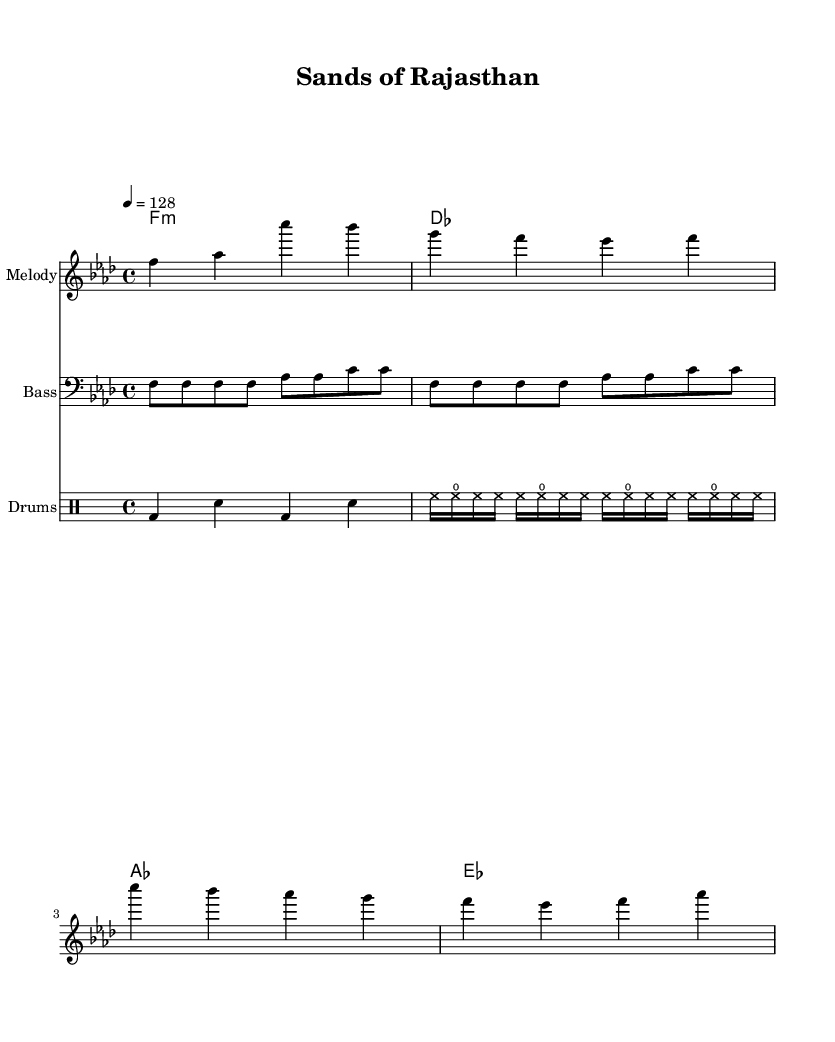What is the key signature of this music? The key signature is F minor, which has four flats. You can identify this by looking at the beginning of the staff where the flats are placed.
Answer: F minor What is the time signature of this piece? The time signature is 4/4, indicated at the beginning of the score. This means there are four beats in each measure.
Answer: 4/4 What is the tempo marking provided in the score? The tempo marking indicates a speed of 128 beats per minute. This is noted above the staff as "4 = 128."
Answer: 128 How many measures are in the melody section? Counting the melody notes visually, the melody contains eight measures. Each measure corresponds to a distinct grouping of beats.
Answer: Eight What instruments are featured in this score? The score includes melody, bass, and drums as indicated by the different staff names. Each of these staff lines represents a different instrument.
Answer: Melody, Bass, Drums What is the primary chord used in the harmony section? The primary chord used in the harmony is F minor, which is the starting chord of the chord progression established in the score. This can be seen at the beginning of the chord section.
Answer: F minor What type of musical style does this piece represent? This piece represents Desert-themed House music, combining ambient sounds with traditional instruments from Rajasthan such as percussion and melodic elements. This can be inferred from the specific references to cultural themes in the description.
Answer: Desert-themed House music 